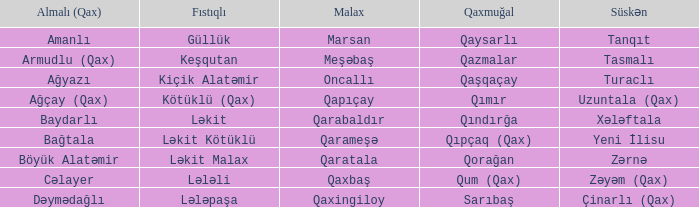What is the Qaxmuğal village with a Malax village meşəbaş? Qazmalar. 